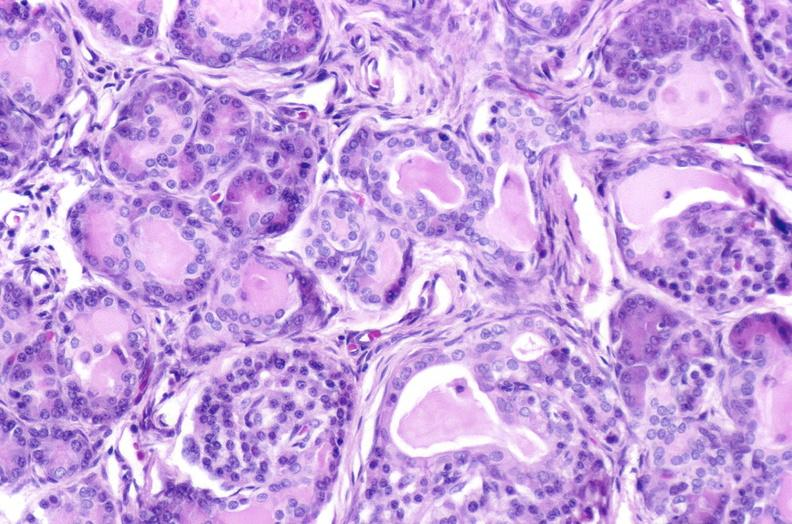does bone, mandible show cystic fibrosis?
Answer the question using a single word or phrase. No 